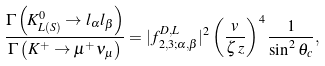<formula> <loc_0><loc_0><loc_500><loc_500>\frac { \Gamma \left ( K ^ { 0 } _ { L ( S ) } \rightarrow l _ { \alpha } l _ { \beta } \right ) } { \Gamma \left ( K ^ { + } \rightarrow \mu ^ { + } \nu _ { \mu } \right ) } = | f ^ { D , L } _ { 2 , 3 ; \alpha , \beta } | ^ { 2 } \left ( \frac { v } { \zeta \, z } \right ) ^ { 4 } \frac { 1 } { \sin ^ { 2 } \theta _ { c } } ,</formula> 